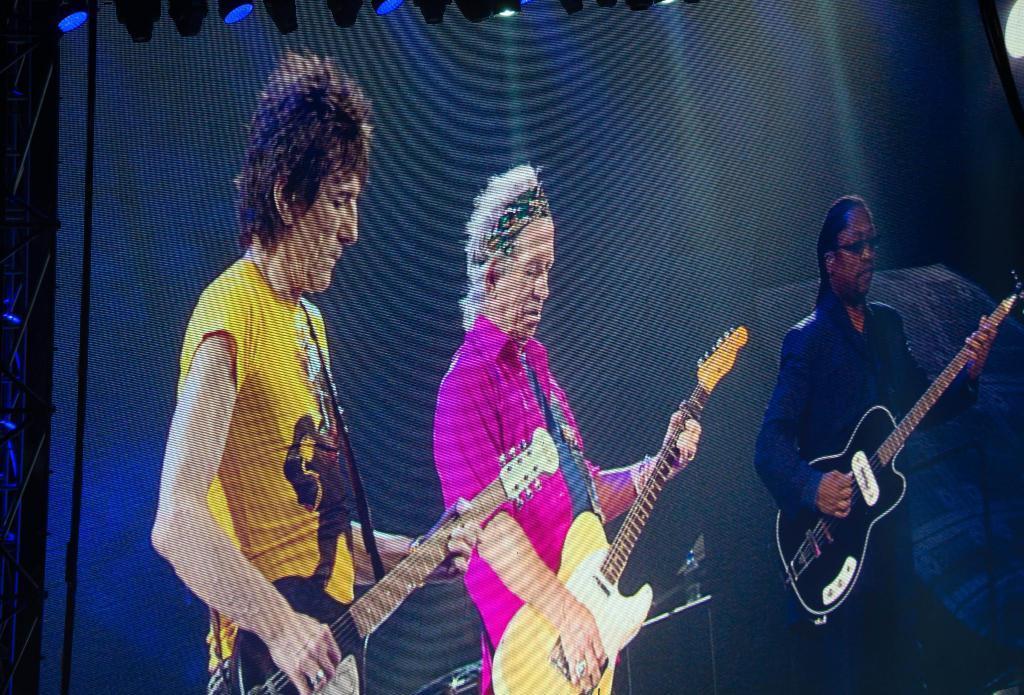Describe this image in one or two sentences. There are three persons holding guitar and playing. In the background there are black curtains. Above there are lights. 